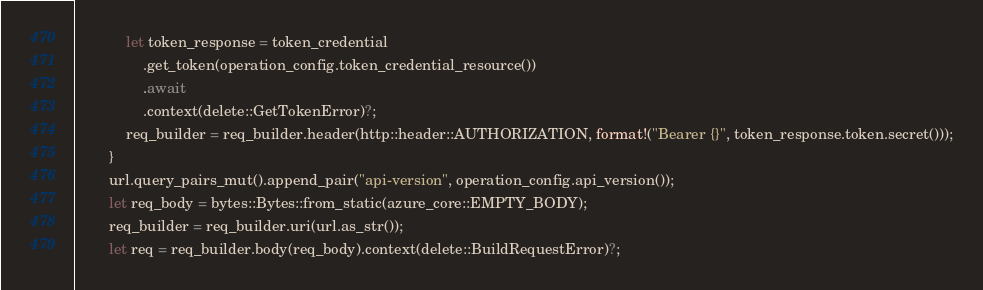<code> <loc_0><loc_0><loc_500><loc_500><_Rust_>            let token_response = token_credential
                .get_token(operation_config.token_credential_resource())
                .await
                .context(delete::GetTokenError)?;
            req_builder = req_builder.header(http::header::AUTHORIZATION, format!("Bearer {}", token_response.token.secret()));
        }
        url.query_pairs_mut().append_pair("api-version", operation_config.api_version());
        let req_body = bytes::Bytes::from_static(azure_core::EMPTY_BODY);
        req_builder = req_builder.uri(url.as_str());
        let req = req_builder.body(req_body).context(delete::BuildRequestError)?;</code> 